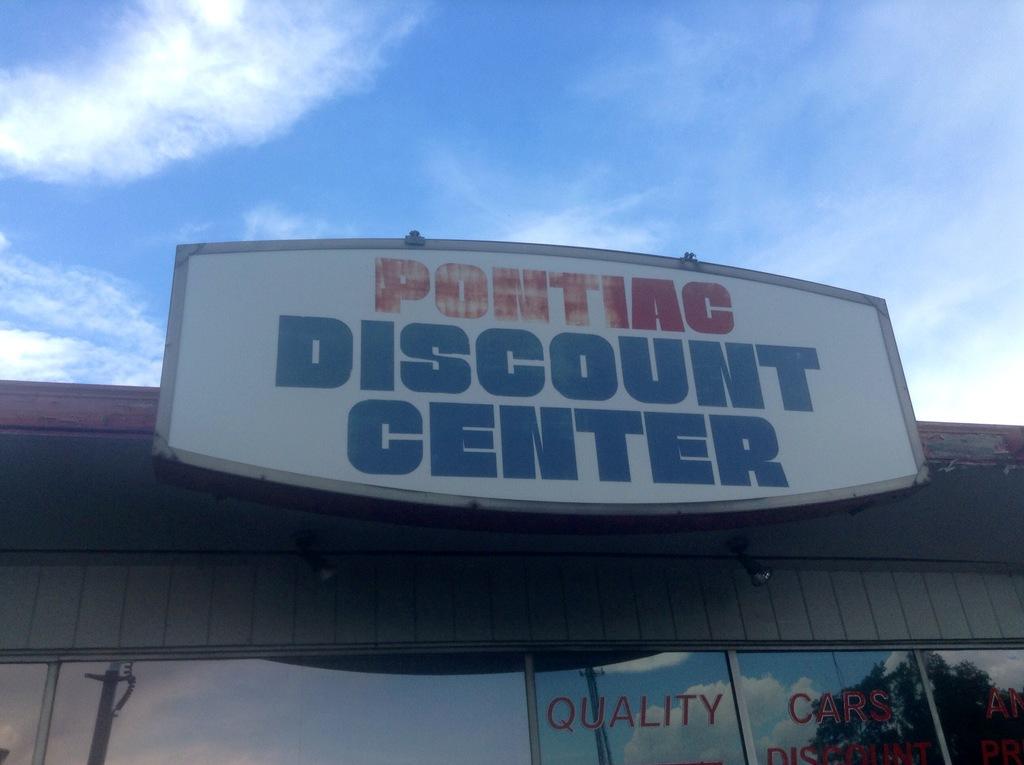Where is the discount center located?
Offer a terse response. Pontiac. 